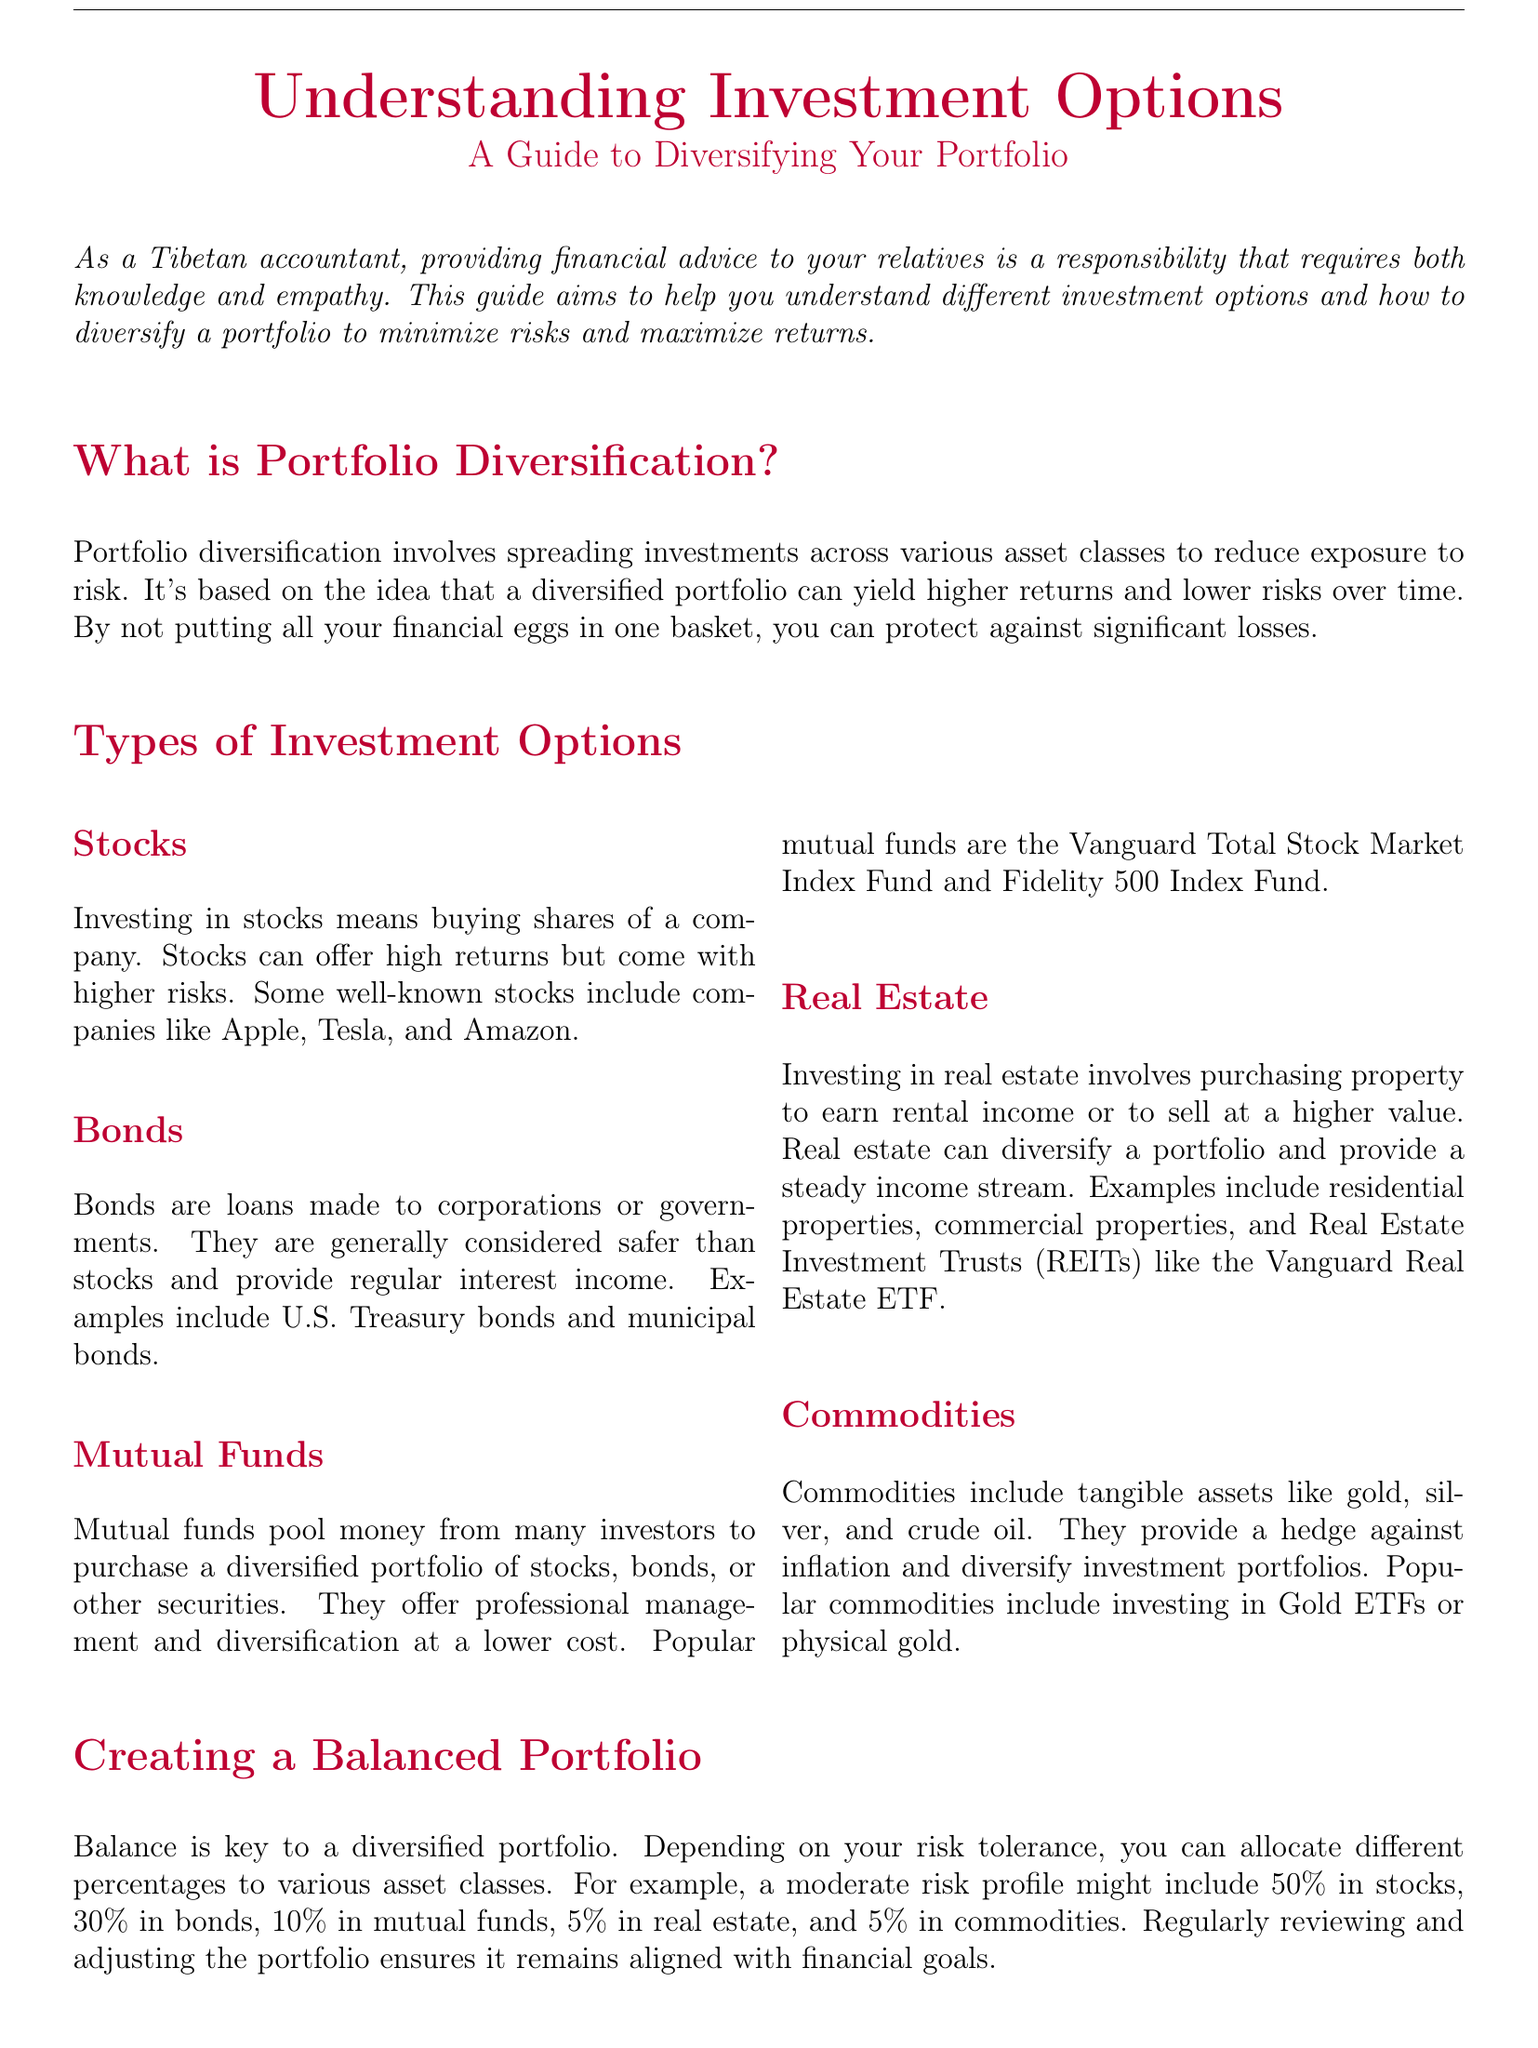What is portfolio diversification? Portfolio diversification involves spreading investments across various asset classes to reduce exposure to risk.
Answer: Spreading investments across various asset classes What types of investments are mentioned? The document lists several types of investments, including stocks, bonds, mutual funds, real estate, and commodities.
Answer: Stocks, bonds, mutual funds, real estate, commodities What percentage of a balanced portfolio is suggested for bonds? The document provides an example allocation for a moderate risk profile that includes 30 percent in bonds.
Answer: 30% Which investment option is considered generally safer than stocks? The document states that bonds are generally considered safer than stocks.
Answer: Bonds What is an example of a mutual fund mentioned? The document refers to popular mutual funds including the Vanguard Total Stock Market Index Fund and Fidelity 500 Index Fund.
Answer: Vanguard Total Stock Market Index Fund What is one reason to invest in commodities? The document mentions that commodities provide a hedge against inflation.
Answer: Hedge against inflation What are the first steps to start investing? The first steps mentioned include assessing risk tolerance and financial goals, researching investment options, starting small, and monitoring investments.
Answer: Assessing risk tolerance and financial goals What does diversification aim to achieve? The main goal of diversification is to achieve long-term financial stability.
Answer: Long-term financial stability 